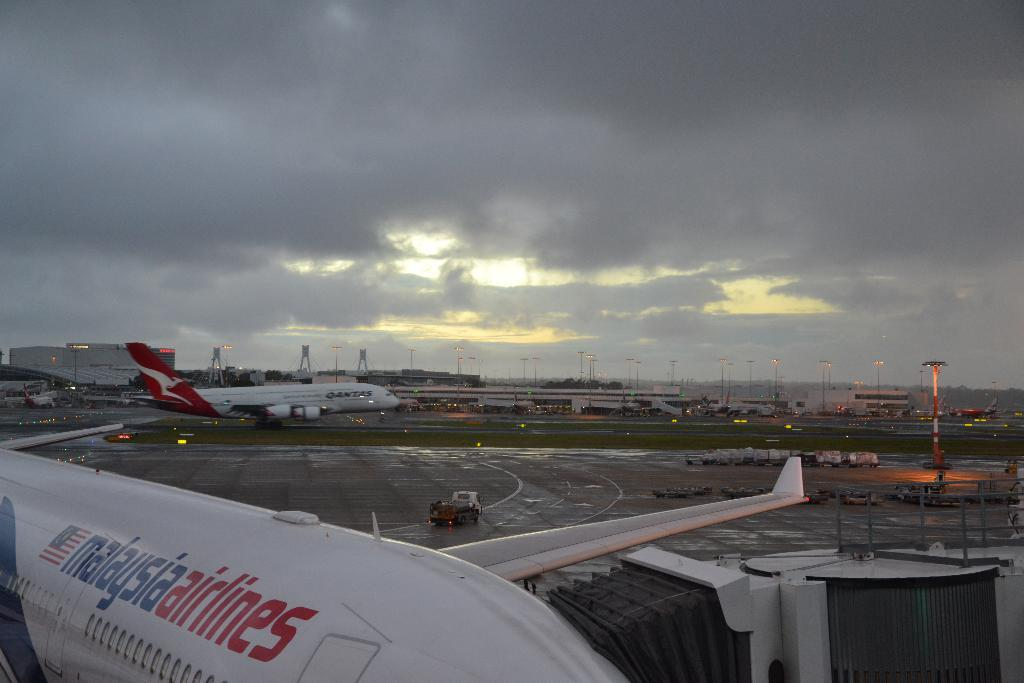<image>
Render a clear and concise summary of the photo. a malasia airlines plane sits with other planes at an airport 